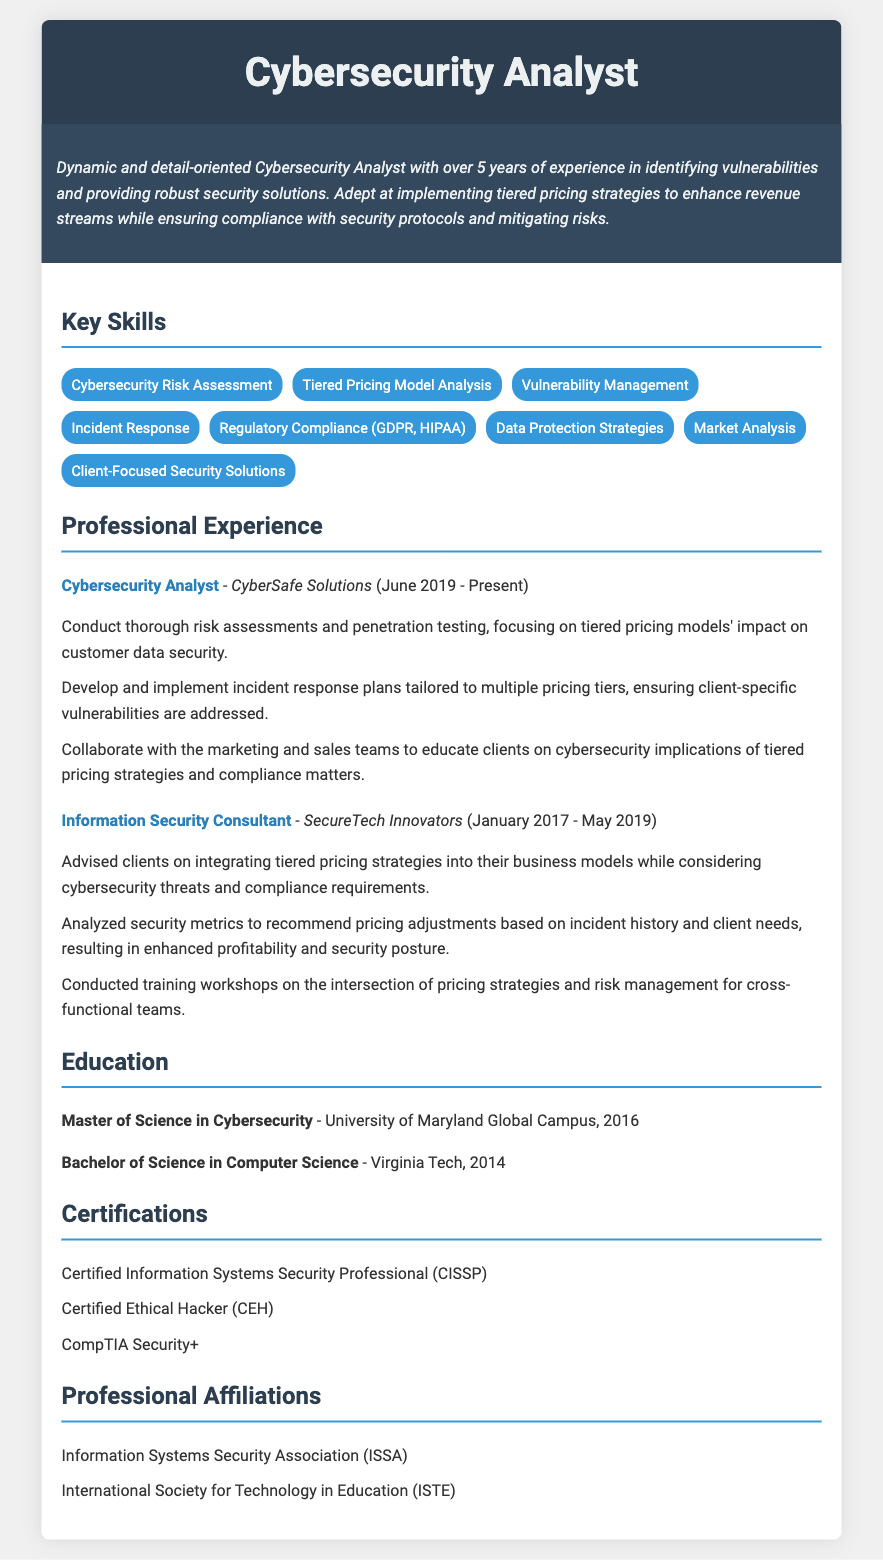what is the total years of experience? The total years of experience can be calculated from the roles listed: 2017 to 2019 is 2 years and 2019 to 2023 is 4 years, totaling 6 years.
Answer: 6 years what is the job title at CyberSafe Solutions? The job title at CyberSafe Solutions is stated as Cybersecurity Analyst in the document.
Answer: Cybersecurity Analyst which university did the candidate attend for their Master's degree? The Master's degree was obtained from the University of Maryland Global Campus, which is mentioned in the education section.
Answer: University of Maryland Global Campus what is one of the certifications held by the candidate? The document lists multiple certifications, one is Certified Information Systems Security Professional (CISSP), found in the certifications section.
Answer: Certified Information Systems Security Professional (CISSP) what are the primary responsibilities of the Cybersecurity Analyst role? The document describes several responsibilities, including conducting risk assessments and developing incident response plans for the Cybersecurity Analyst role.
Answer: Conduct thorough risk assessments how did the candidate enhance profitability related to tiered pricing strategies? The candidate recommended pricing adjustments based on incident history and client needs to enhance profitability, as detailed in the professional experience section.
Answer: Recommended pricing adjustments who collaborated with the candidate to educate clients on cybersecurity implications? The candidate worked with the marketing and sales teams, as mentioned in the experience section, to inform clients about tiered pricing strategies.
Answer: Marketing and sales teams how many professional affiliations are listed? The document lists two professional affiliations under the professional affiliations section.
Answer: 2 what skill focuses on the relationship between pricing and security? The skill specifically addressing the pricing and security relationship is Tiered Pricing Model Analysis, identified in the key skills section.
Answer: Tiered Pricing Model Analysis 